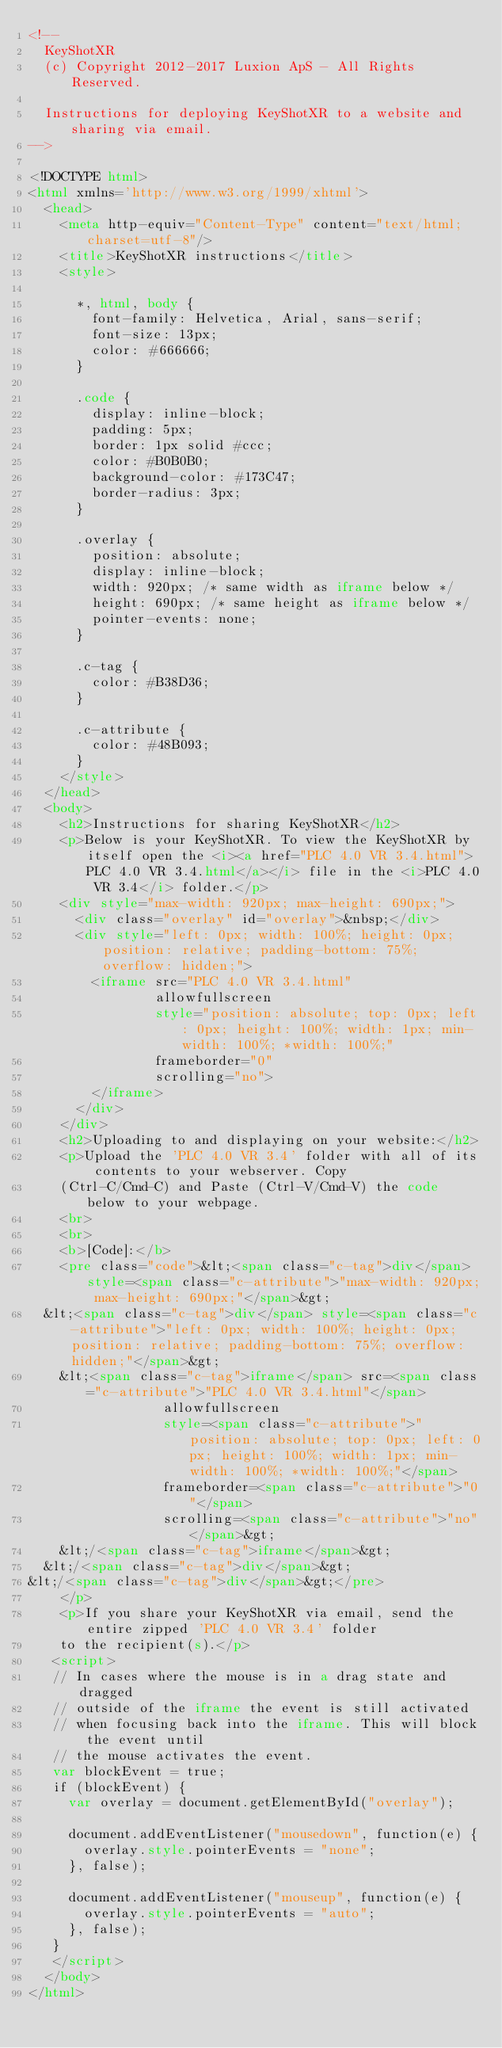Convert code to text. <code><loc_0><loc_0><loc_500><loc_500><_HTML_><!--
  KeyShotXR
  (c) Copyright 2012-2017 Luxion ApS - All Rights Reserved.

  Instructions for deploying KeyShotXR to a website and sharing via email.
-->

<!DOCTYPE html>
<html xmlns='http://www.w3.org/1999/xhtml'>
  <head>
    <meta http-equiv="Content-Type" content="text/html; charset=utf-8"/>
    <title>KeyShotXR instructions</title>
    <style>

      *, html, body {
        font-family: Helvetica, Arial, sans-serif;
        font-size: 13px;
        color: #666666;
      }

      .code {
        display: inline-block;
        padding: 5px;
        border: 1px solid #ccc;
        color: #B0B0B0;
        background-color: #173C47;
        border-radius: 3px;
      }

      .overlay {
        position: absolute;
        display: inline-block;
        width: 920px; /* same width as iframe below */
        height: 690px; /* same height as iframe below */
        pointer-events: none;
      }

      .c-tag {
        color: #B38D36;
      }

      .c-attribute {
        color: #48B093;
      }
    </style>
  </head>
  <body>
    <h2>Instructions for sharing KeyShotXR</h2>
    <p>Below is your KeyShotXR. To view the KeyShotXR by itself open the <i><a href="PLC 4.0 VR 3.4.html">PLC 4.0 VR 3.4.html</a></i> file in the <i>PLC 4.0 VR 3.4</i> folder.</p>
    <div style="max-width: 920px; max-height: 690px;">
      <div class="overlay" id="overlay">&nbsp;</div>
      <div style="left: 0px; width: 100%; height: 0px; position: relative; padding-bottom: 75%; overflow: hidden;">
        <iframe src="PLC 4.0 VR 3.4.html"
                allowfullscreen
                style="position: absolute; top: 0px; left: 0px; height: 100%; width: 1px; min-width: 100%; *width: 100%;"
                frameborder="0"
                scrolling="no">
        </iframe>
      </div>
    </div>
    <h2>Uploading to and displaying on your website:</h2>
    <p>Upload the 'PLC 4.0 VR 3.4' folder with all of its contents to your webserver. Copy
    (Ctrl-C/Cmd-C) and Paste (Ctrl-V/Cmd-V) the code below to your webpage.
    <br>
    <br>
    <b>[Code]:</b>
    <pre class="code">&lt;<span class="c-tag">div</span> style=<span class="c-attribute">"max-width: 920px; max-height: 690px;"</span>&gt;
  &lt;<span class="c-tag">div</span> style=<span class="c-attribute">"left: 0px; width: 100%; height: 0px; position: relative; padding-bottom: 75%; overflow: hidden;"</span>&gt;
    &lt;<span class="c-tag">iframe</span> src=<span class="c-attribute">"PLC 4.0 VR 3.4.html"</span>
                 allowfullscreen
                 style=<span class="c-attribute">"position: absolute; top: 0px; left: 0px; height: 100%; width: 1px; min-width: 100%; *width: 100%;"</span>
                 frameborder=<span class="c-attribute">"0"</span>
                 scrolling=<span class="c-attribute">"no"</span>&gt;
    &lt;/<span class="c-tag">iframe</span>&gt;
  &lt;/<span class="c-tag">div</span>&gt;
&lt;/<span class="c-tag">div</span>&gt;</pre>
    </p>
    <p>If you share your KeyShotXR via email, send the entire zipped 'PLC 4.0 VR 3.4' folder
    to the recipient(s).</p>
   <script>
   // In cases where the mouse is in a drag state and dragged
   // outside of the iframe the event is still activated
   // when focusing back into the iframe. This will block the event until
   // the mouse activates the event.
   var blockEvent = true;
   if (blockEvent) {
     var overlay = document.getElementById("overlay");

     document.addEventListener("mousedown", function(e) {
       overlay.style.pointerEvents = "none";
     }, false);

     document.addEventListener("mouseup", function(e) {
       overlay.style.pointerEvents = "auto";
     }, false);
   }
   </script>
  </body>
</html>
</code> 